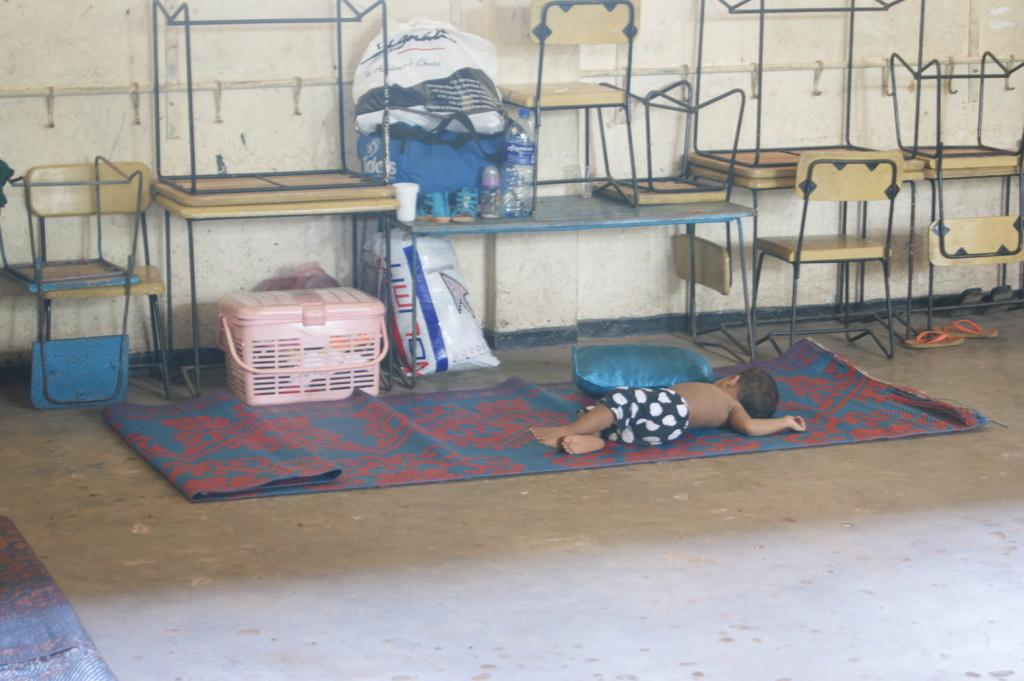What is the main object in the center of the image? There is a pillow in the center of the image. What is the baby doing in the image? A baby is sleeping on a mat in the image. What type of furniture can be seen in the background of the image? There are benches, chairs, and containers visible in the background of the image. What type of coverings are present in the background of the image? Covers are present in the background of the image. What type of bottles are visible in the background of the image? Bottles are visible in the background of the image. What type of footwear is present in the background of the image? Slippers are present in the background of the image. What type of structure is visible in the background of the image? There is a wall in the background of the image. What type of question is being asked by the van in the image? There is no van present in the image, and therefore no questions are being asked by a van. What type of lipstick is being used by the baby in the image? There is no lipstick or baby applying lipstick in the image. 